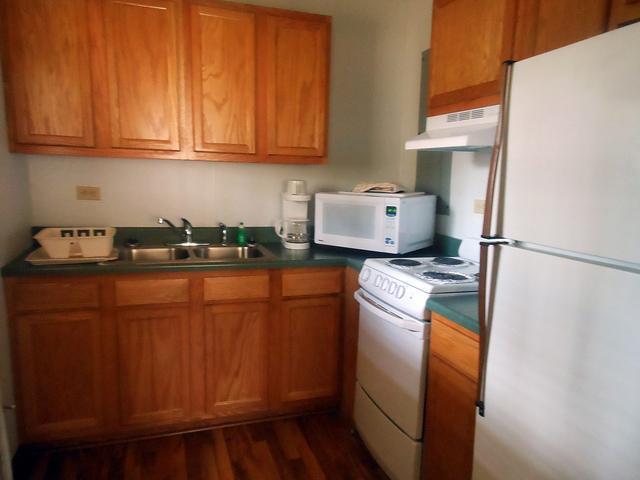How many microwaves are there?
Give a very brief answer. 1. 